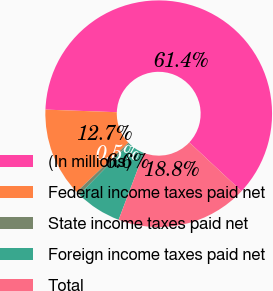<chart> <loc_0><loc_0><loc_500><loc_500><pie_chart><fcel>(In millions)<fcel>Federal income taxes paid net<fcel>State income taxes paid net<fcel>Foreign income taxes paid net<fcel>Total<nl><fcel>61.39%<fcel>12.7%<fcel>0.52%<fcel>6.61%<fcel>18.78%<nl></chart> 